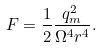<formula> <loc_0><loc_0><loc_500><loc_500>F = \frac { 1 } { 2 } \frac { q _ { m } ^ { 2 } } { \Omega ^ { 4 } r ^ { 4 } } .</formula> 